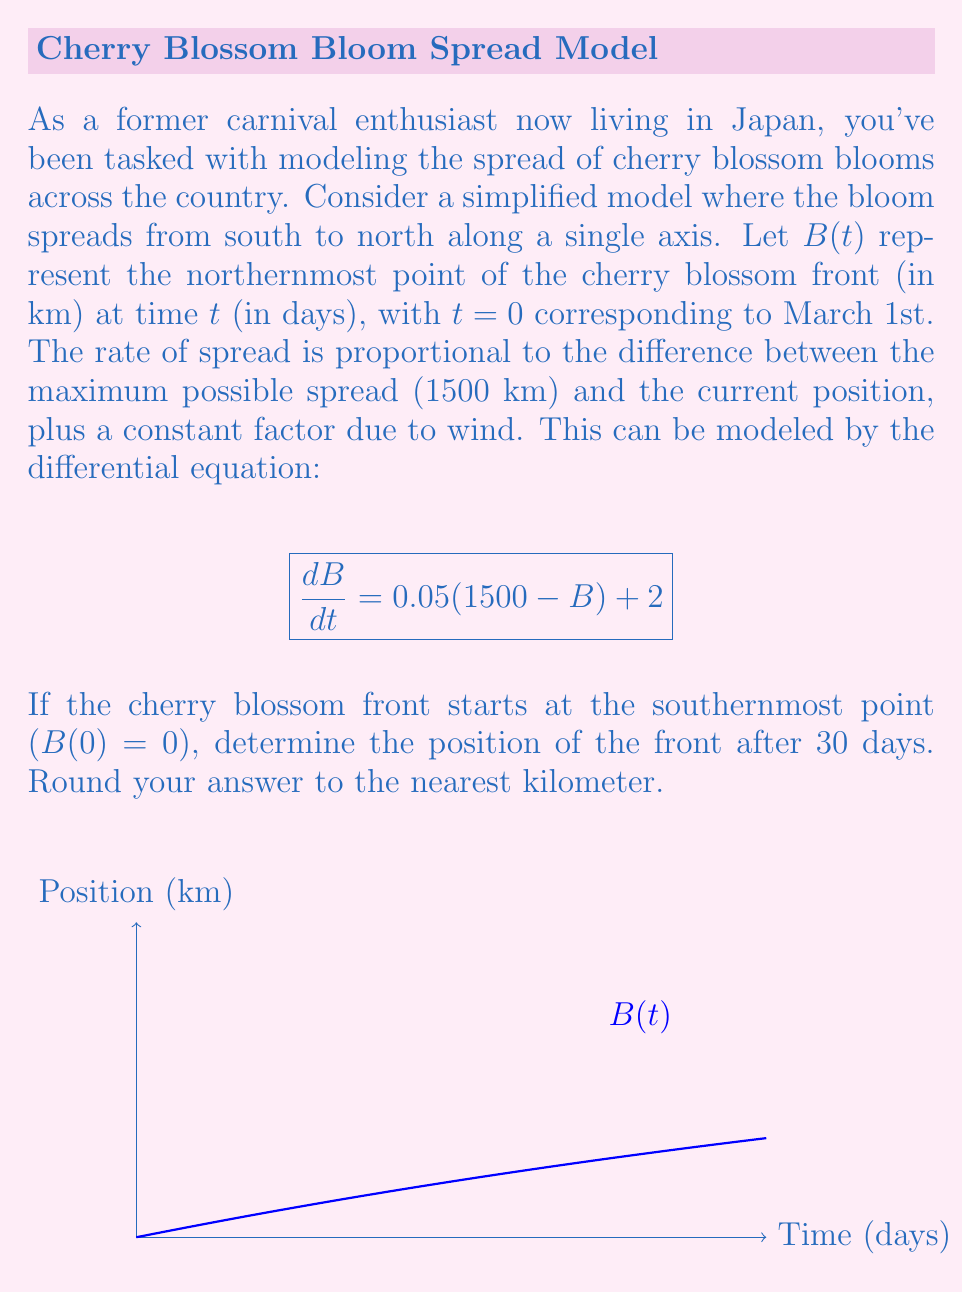Provide a solution to this math problem. Let's solve this step-by-step:

1) We have the differential equation:
   $$\frac{dB}{dt} = 0.05(1500 - B) + 2$$

2) This is a first-order linear differential equation of the form:
   $$\frac{dB}{dt} + 0.05B = 77$$

3) The general solution for this type of equation is:
   $$B(t) = Ce^{-0.05t} + 1540$$
   where $C$ is a constant and 1540 is the particular solution.

4) To find $C$, we use the initial condition $B(0) = 0$:
   $$0 = C + 1540$$
   $$C = -1540$$

5) Therefore, the specific solution is:
   $$B(t) = 1540(1 - e^{-0.05t})$$

6) Now, we need to find $B(30)$:
   $$B(30) = 1540(1 - e^{-0.05 * 30})$$
   $$= 1540(1 - e^{-1.5})$$
   $$\approx 1540(1 - 0.2231)$$
   $$\approx 1196.43$$

7) Rounding to the nearest kilometer:
   $$B(30) \approx 1196 \text{ km}$$
Answer: 1196 km 